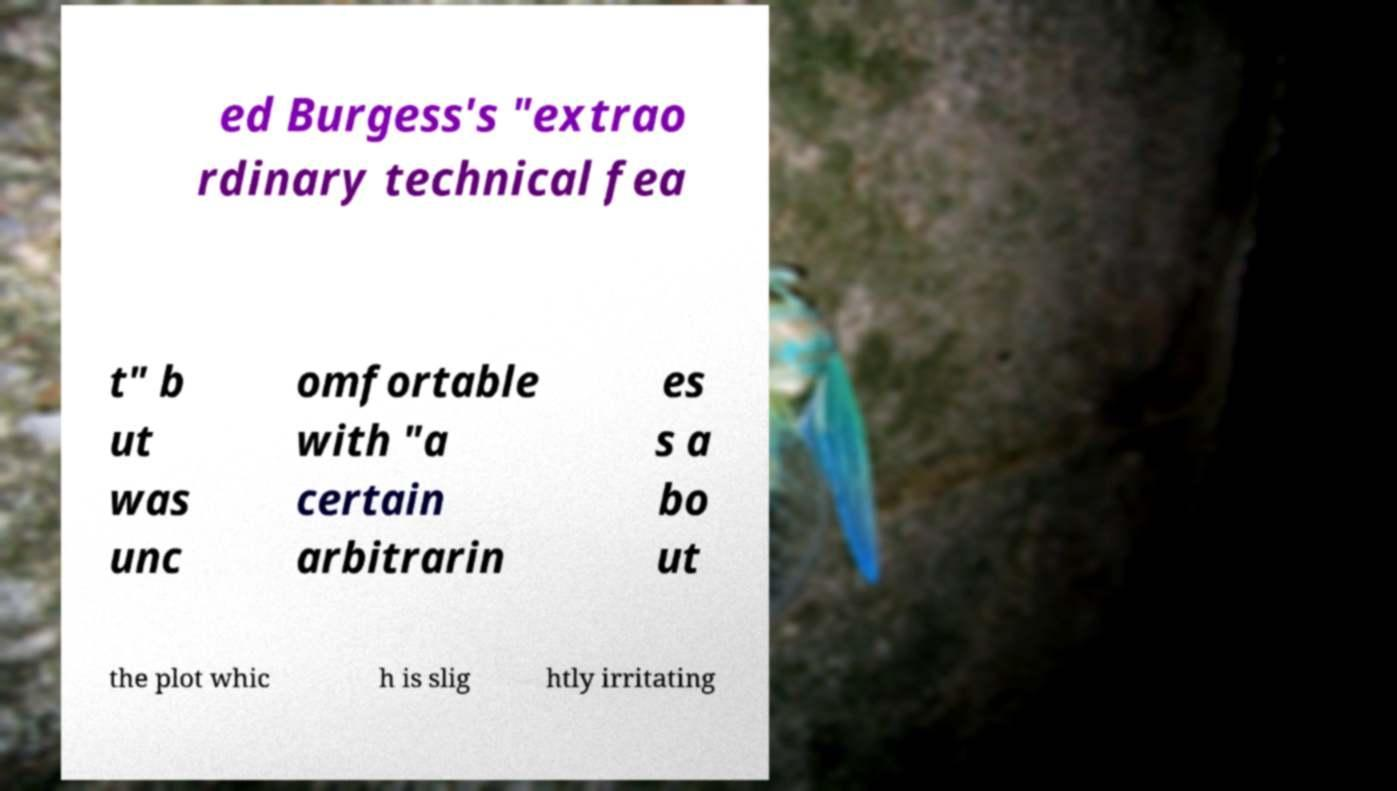Can you read and provide the text displayed in the image?This photo seems to have some interesting text. Can you extract and type it out for me? ed Burgess's "extrao rdinary technical fea t" b ut was unc omfortable with "a certain arbitrarin es s a bo ut the plot whic h is slig htly irritating 